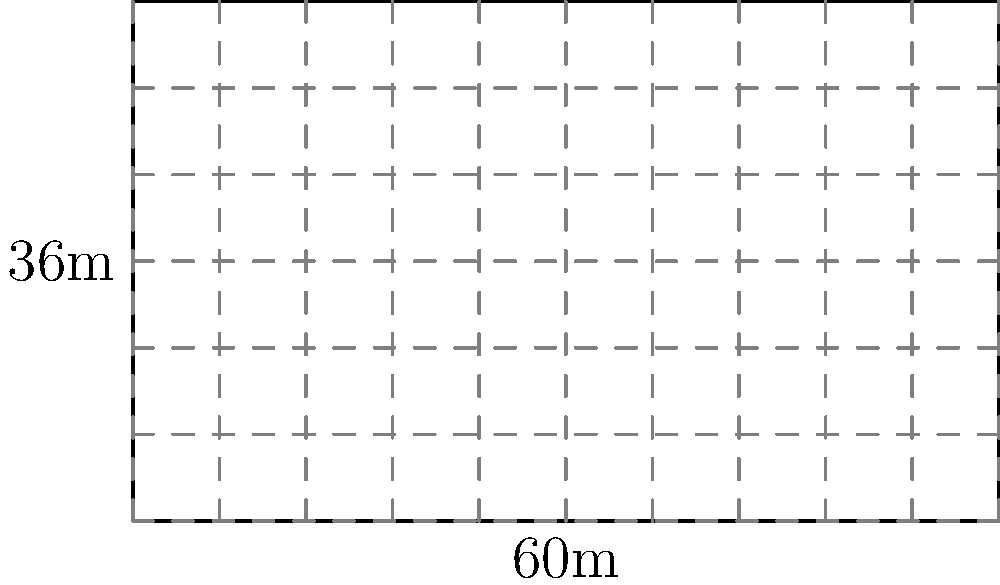You've been tasked with optimizing the cubicle layout in your company's new rectangular office space, which measures 60m by 36m. Each cubicle is a perfect square, 3m on each side. Ignoring any space for walkways or common areas, what is the maximum number of cubicles that can fit in this office space? To solve this problem efficiently, we'll follow these steps:

1) First, let's calculate the area of the office space:
   Area of office = length × width
   $$ A_{office} = 60\text{m} \times 36\text{m} = 2160\text{m}^2 $$

2) Now, let's calculate the area of each cubicle:
   Area of cubicle = side length × side length
   $$ A_{cubicle} = 3\text{m} \times 3\text{m} = 9\text{m}^2 $$

3) To find the maximum number of cubicles, we divide the total office area by the area of one cubicle:
   $$ \text{Number of cubicles} = \frac{A_{office}}{A_{cubicle}} = \frac{2160\text{m}^2}{9\text{m}^2} = 240 $$

4) Since we can't have a fraction of a cubicle, we round down to the nearest whole number.

Therefore, the maximum number of 3m × 3m cubicles that can fit in this 60m × 36m office space is 240.

Note: This calculation assumes perfect efficiency and doesn't account for necessary walkways or common areas, which would be impractical in a real office setting. However, it does answer the question of the maximum theoretical number of cubicles.
Answer: 240 cubicles 